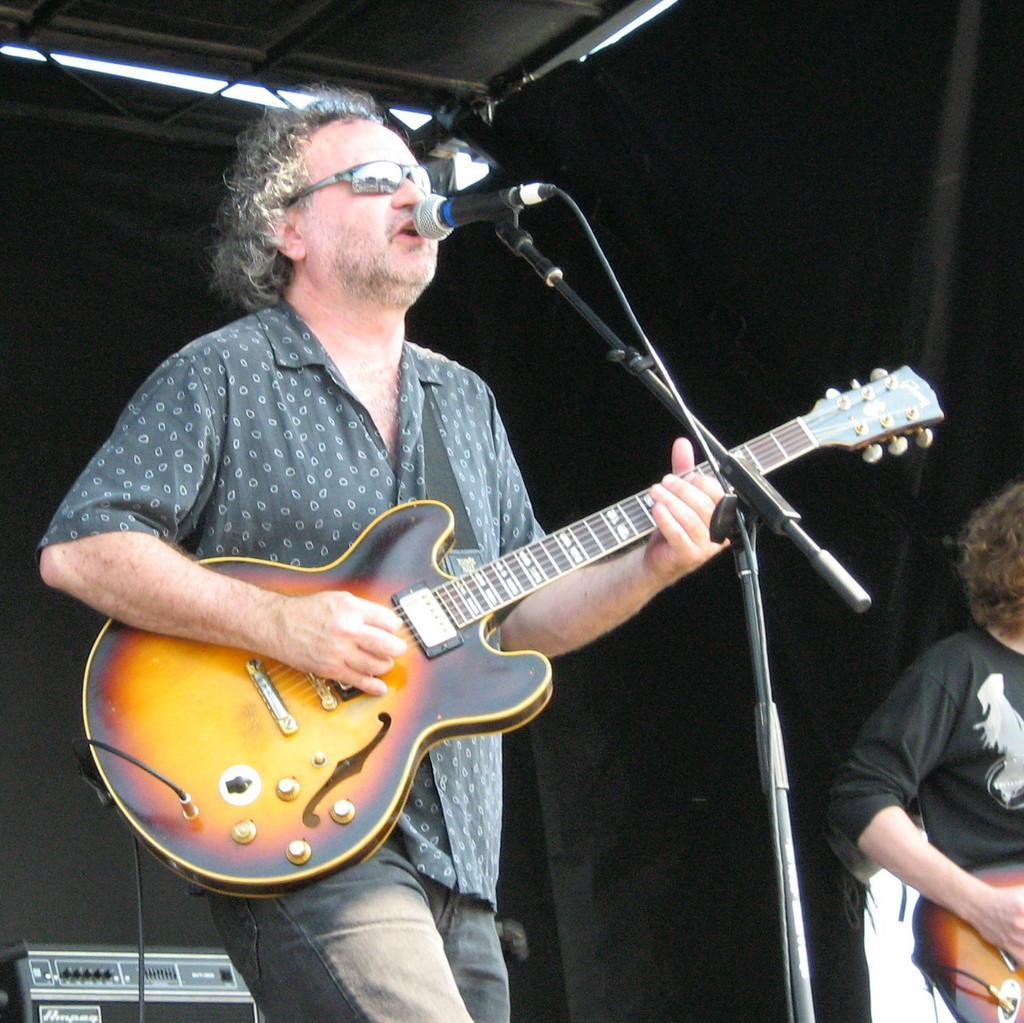Please provide a concise description of this image. This is a man standing and playing guitar. He is singing a song using the mike. This mic is attached to the mike stand. At the right side I can see another person standing and playing guitar. This looks like an electronic device. At background this is a black cloth hanging. 